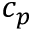<formula> <loc_0><loc_0><loc_500><loc_500>c _ { p }</formula> 